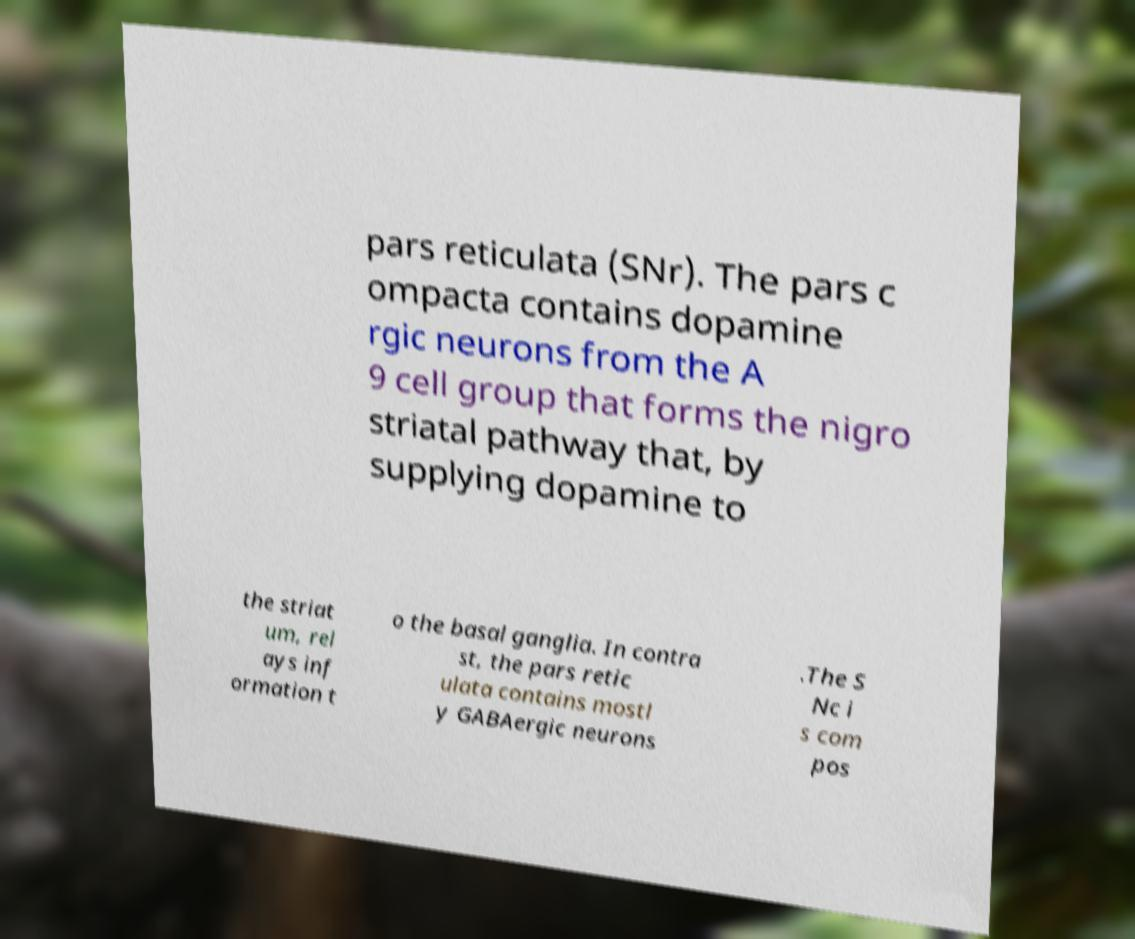Please read and relay the text visible in this image. What does it say? pars reticulata (SNr). The pars c ompacta contains dopamine rgic neurons from the A 9 cell group that forms the nigro striatal pathway that, by supplying dopamine to the striat um, rel ays inf ormation t o the basal ganglia. In contra st, the pars retic ulata contains mostl y GABAergic neurons .The S Nc i s com pos 